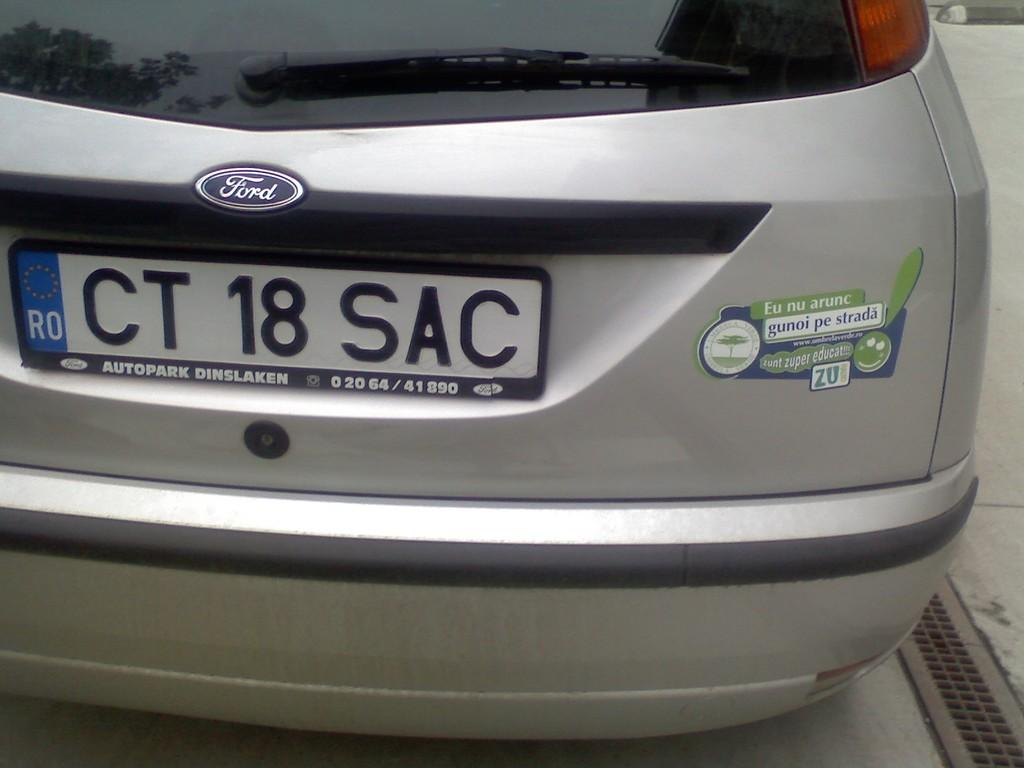<image>
Summarize the visual content of the image. A ford car with license plate CT 18 SAC 